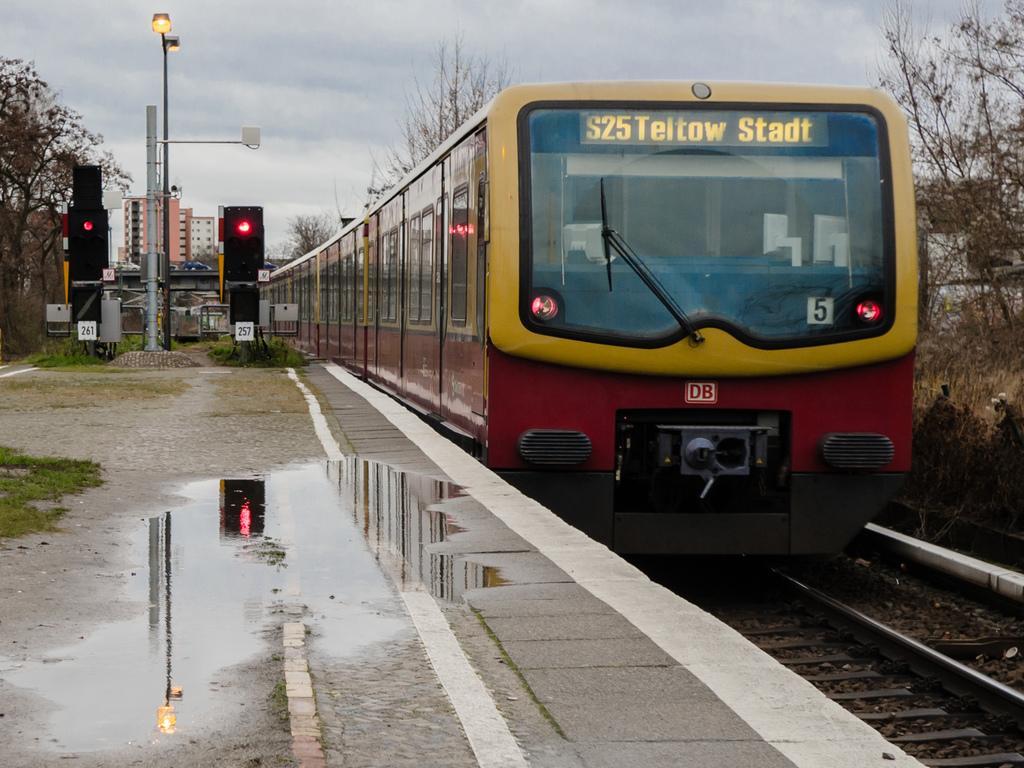Describe this image in one or two sentences. In this image, we can see a train on the track. There are poles and signal lights on the platform. There is a tree in the top left and in the top right of the image. There is a sky at the top of the image. 